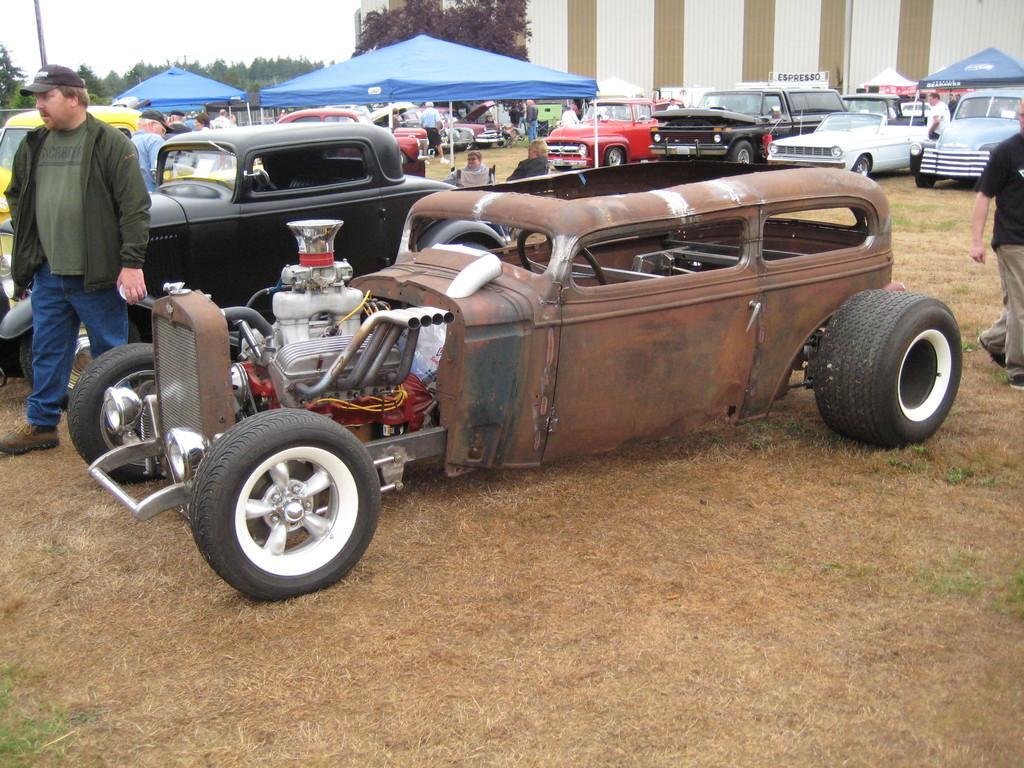Please provide a concise description of this image. In the picture I can see the cars. I can see a man on the top left side is wearing a jacket and there is a cap on his head. There is a man walking on the grass and he is on the top right side. In the background, I can see a few people standing in front of the cars, tents and trees. 